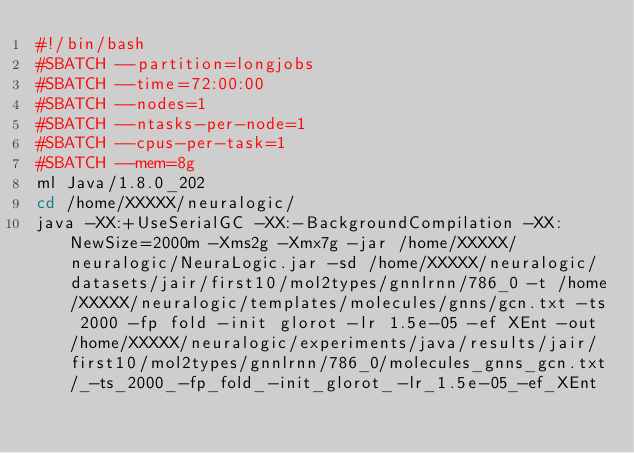Convert code to text. <code><loc_0><loc_0><loc_500><loc_500><_Bash_>#!/bin/bash
#SBATCH --partition=longjobs
#SBATCH --time=72:00:00
#SBATCH --nodes=1
#SBATCH --ntasks-per-node=1
#SBATCH --cpus-per-task=1
#SBATCH --mem=8g
ml Java/1.8.0_202 
cd /home/XXXXX/neuralogic/
java -XX:+UseSerialGC -XX:-BackgroundCompilation -XX:NewSize=2000m -Xms2g -Xmx7g -jar /home/XXXXX/neuralogic/NeuraLogic.jar -sd /home/XXXXX/neuralogic/datasets/jair/first10/mol2types/gnnlrnn/786_0 -t /home/XXXXX/neuralogic/templates/molecules/gnns/gcn.txt -ts 2000 -fp fold -init glorot -lr 1.5e-05 -ef XEnt -out /home/XXXXX/neuralogic/experiments/java/results/jair/first10/mol2types/gnnlrnn/786_0/molecules_gnns_gcn.txt/_-ts_2000_-fp_fold_-init_glorot_-lr_1.5e-05_-ef_XEnt</code> 